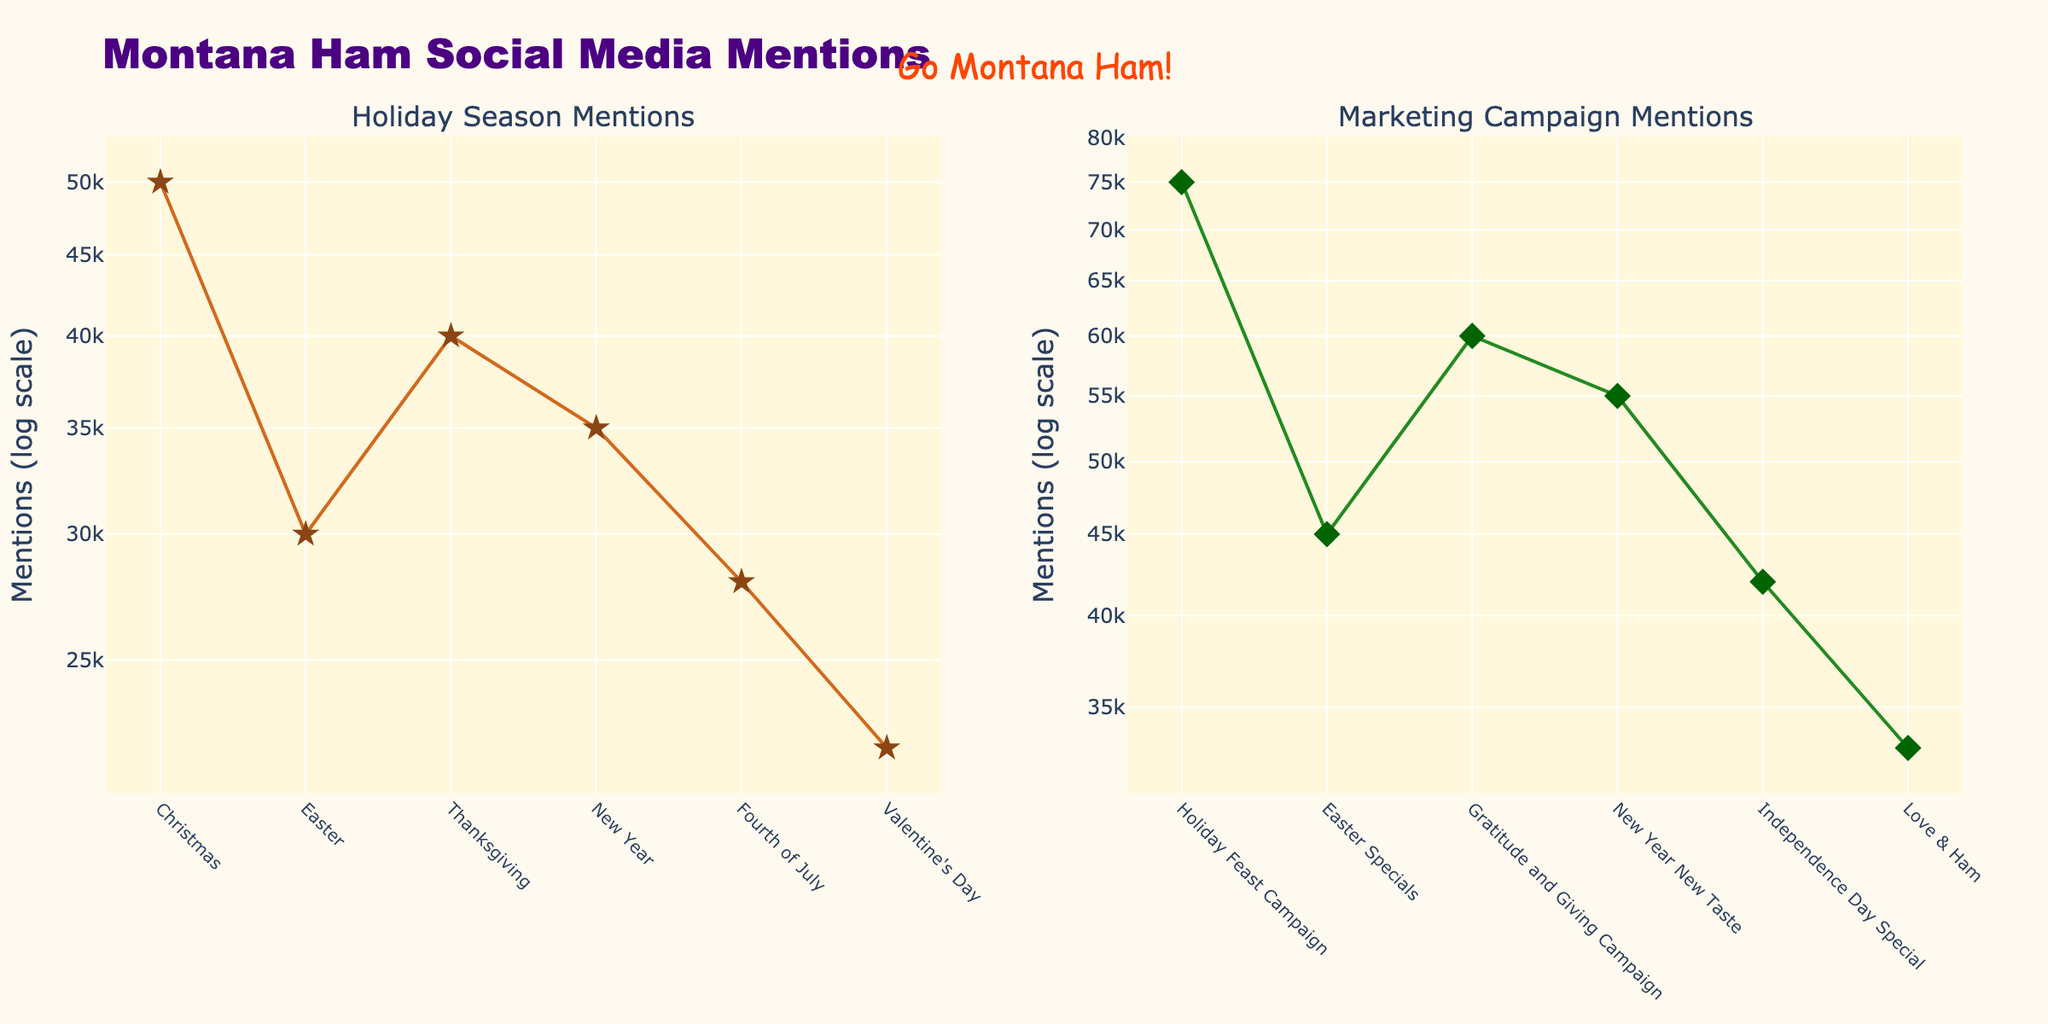What's the title of the figure? The title is written at the top center of the figure and reads "Montana Ham Social Media Mentions".
Answer: Montana Ham Social Media Mentions What is the y-axis scale used in the plot? The y-axis labels show powers of 10, indicating that a logarithmic scale is used. The y-axis is labeled "Mentions (log scale)".
Answer: Logarithmic How many holiday seasons are represented in the left subplot? By counting the distinct markers or labels on the x-axis of the left subplot, we see there are six holiday seasons represented: Christmas, Easter, Thanksgiving, New Year, Fourth of July, and Valentine's Day.
Answer: Six Which marketing campaign had the most mentions? Looking at the y-values of the markers in the right subplot, the "Holiday Feast Campaign" during Christmas has the highest mention count.
Answer: Holiday Feast Campaign What's the difference in Montana Ham mentions between the highest and lowest holidays? The highest mention is during Christmas with 50,000 mentions, and the lowest is on Valentine's Day with 22,000 mentions. The difference is calculated as 50,000 - 22,000 = 28,000.
Answer: 28,000 What's the average number of mentions for the marketing campaigns? Summing the campaign mentions: 75,000 (Christmas) + 45,000 (Easter) + 60,000 (Thanksgiving) + 55,000 (New Year) + 42,000 (Fourth of July) + 33,000 (Valentine's Day) = 310,000. Then, divide by 6 (number of campaigns), which gives 310,000 / 6 ≈ 51,667.
Answer: 51,667 Which holiday had fewer mentions than the average marketing campaign mentions? The average marketing campaign mentions are approximately 51,667. The holidays with mentions fewer than this are Easter (30,000), New Year (35,000), Fourth of July (28,000), and Valentine's Day (22,000).
Answer: Easter, New Year, Fourth of July, Valentine's Day Are the trends in Montana Ham mentions and marketing campaign mentions always proportional? By visually comparing the trends in both subplots, there is a general proportional trend where higher holiday mentions roughly correspond to higher campaign mentions, but they are not perfectly proportional.
Answer: No What annotation is added in the figure? The annotation can be seen above the subplots and reads "Go Montana Ham!" with specific font details.
Answer: Go Montana Ham! 